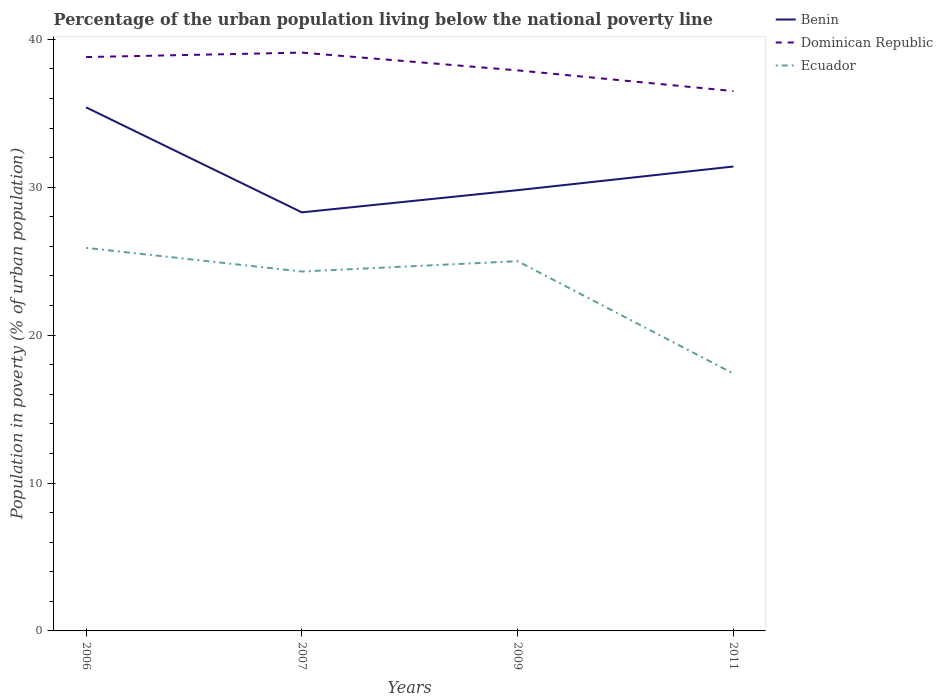How many different coloured lines are there?
Give a very brief answer. 3. Does the line corresponding to Benin intersect with the line corresponding to Dominican Republic?
Provide a short and direct response. No. Is the number of lines equal to the number of legend labels?
Make the answer very short. Yes. Across all years, what is the maximum percentage of the urban population living below the national poverty line in Dominican Republic?
Your response must be concise. 36.5. In which year was the percentage of the urban population living below the national poverty line in Ecuador maximum?
Give a very brief answer. 2011. What is the total percentage of the urban population living below the national poverty line in Dominican Republic in the graph?
Offer a very short reply. 2.6. What is the difference between the highest and the second highest percentage of the urban population living below the national poverty line in Benin?
Provide a short and direct response. 7.1. What is the difference between the highest and the lowest percentage of the urban population living below the national poverty line in Dominican Republic?
Your answer should be compact. 2. How many lines are there?
Keep it short and to the point. 3. What is the difference between two consecutive major ticks on the Y-axis?
Provide a short and direct response. 10. Does the graph contain grids?
Provide a short and direct response. No. Where does the legend appear in the graph?
Provide a short and direct response. Top right. How many legend labels are there?
Your answer should be very brief. 3. What is the title of the graph?
Keep it short and to the point. Percentage of the urban population living below the national poverty line. Does "Norway" appear as one of the legend labels in the graph?
Provide a short and direct response. No. What is the label or title of the Y-axis?
Your response must be concise. Population in poverty (% of urban population). What is the Population in poverty (% of urban population) of Benin in 2006?
Offer a terse response. 35.4. What is the Population in poverty (% of urban population) of Dominican Republic in 2006?
Offer a very short reply. 38.8. What is the Population in poverty (% of urban population) in Ecuador in 2006?
Your response must be concise. 25.9. What is the Population in poverty (% of urban population) in Benin in 2007?
Your answer should be very brief. 28.3. What is the Population in poverty (% of urban population) in Dominican Republic in 2007?
Offer a terse response. 39.1. What is the Population in poverty (% of urban population) in Ecuador in 2007?
Give a very brief answer. 24.3. What is the Population in poverty (% of urban population) in Benin in 2009?
Give a very brief answer. 29.8. What is the Population in poverty (% of urban population) in Dominican Republic in 2009?
Ensure brevity in your answer.  37.9. What is the Population in poverty (% of urban population) in Ecuador in 2009?
Give a very brief answer. 25. What is the Population in poverty (% of urban population) of Benin in 2011?
Give a very brief answer. 31.4. What is the Population in poverty (% of urban population) in Dominican Republic in 2011?
Your response must be concise. 36.5. What is the Population in poverty (% of urban population) of Ecuador in 2011?
Your response must be concise. 17.4. Across all years, what is the maximum Population in poverty (% of urban population) in Benin?
Make the answer very short. 35.4. Across all years, what is the maximum Population in poverty (% of urban population) of Dominican Republic?
Your answer should be very brief. 39.1. Across all years, what is the maximum Population in poverty (% of urban population) of Ecuador?
Make the answer very short. 25.9. Across all years, what is the minimum Population in poverty (% of urban population) of Benin?
Provide a succinct answer. 28.3. Across all years, what is the minimum Population in poverty (% of urban population) of Dominican Republic?
Provide a succinct answer. 36.5. What is the total Population in poverty (% of urban population) in Benin in the graph?
Offer a very short reply. 124.9. What is the total Population in poverty (% of urban population) in Dominican Republic in the graph?
Keep it short and to the point. 152.3. What is the total Population in poverty (% of urban population) of Ecuador in the graph?
Your response must be concise. 92.6. What is the difference between the Population in poverty (% of urban population) of Benin in 2006 and that in 2007?
Make the answer very short. 7.1. What is the difference between the Population in poverty (% of urban population) of Dominican Republic in 2006 and that in 2007?
Your response must be concise. -0.3. What is the difference between the Population in poverty (% of urban population) in Ecuador in 2006 and that in 2007?
Give a very brief answer. 1.6. What is the difference between the Population in poverty (% of urban population) in Dominican Republic in 2006 and that in 2009?
Your response must be concise. 0.9. What is the difference between the Population in poverty (% of urban population) in Ecuador in 2006 and that in 2009?
Give a very brief answer. 0.9. What is the difference between the Population in poverty (% of urban population) of Benin in 2006 and that in 2011?
Make the answer very short. 4. What is the difference between the Population in poverty (% of urban population) of Benin in 2007 and that in 2009?
Your answer should be very brief. -1.5. What is the difference between the Population in poverty (% of urban population) in Dominican Republic in 2007 and that in 2009?
Offer a terse response. 1.2. What is the difference between the Population in poverty (% of urban population) of Benin in 2007 and that in 2011?
Make the answer very short. -3.1. What is the difference between the Population in poverty (% of urban population) of Ecuador in 2007 and that in 2011?
Offer a terse response. 6.9. What is the difference between the Population in poverty (% of urban population) of Ecuador in 2009 and that in 2011?
Your answer should be very brief. 7.6. What is the difference between the Population in poverty (% of urban population) of Benin in 2006 and the Population in poverty (% of urban population) of Dominican Republic in 2009?
Keep it short and to the point. -2.5. What is the difference between the Population in poverty (% of urban population) in Benin in 2006 and the Population in poverty (% of urban population) in Dominican Republic in 2011?
Keep it short and to the point. -1.1. What is the difference between the Population in poverty (% of urban population) in Dominican Republic in 2006 and the Population in poverty (% of urban population) in Ecuador in 2011?
Offer a terse response. 21.4. What is the difference between the Population in poverty (% of urban population) of Benin in 2007 and the Population in poverty (% of urban population) of Ecuador in 2009?
Provide a short and direct response. 3.3. What is the difference between the Population in poverty (% of urban population) in Dominican Republic in 2007 and the Population in poverty (% of urban population) in Ecuador in 2009?
Your answer should be compact. 14.1. What is the difference between the Population in poverty (% of urban population) of Benin in 2007 and the Population in poverty (% of urban population) of Dominican Republic in 2011?
Your response must be concise. -8.2. What is the difference between the Population in poverty (% of urban population) in Benin in 2007 and the Population in poverty (% of urban population) in Ecuador in 2011?
Give a very brief answer. 10.9. What is the difference between the Population in poverty (% of urban population) of Dominican Republic in 2007 and the Population in poverty (% of urban population) of Ecuador in 2011?
Give a very brief answer. 21.7. What is the difference between the Population in poverty (% of urban population) of Benin in 2009 and the Population in poverty (% of urban population) of Dominican Republic in 2011?
Make the answer very short. -6.7. What is the difference between the Population in poverty (% of urban population) in Dominican Republic in 2009 and the Population in poverty (% of urban population) in Ecuador in 2011?
Provide a succinct answer. 20.5. What is the average Population in poverty (% of urban population) of Benin per year?
Your response must be concise. 31.23. What is the average Population in poverty (% of urban population) in Dominican Republic per year?
Make the answer very short. 38.08. What is the average Population in poverty (% of urban population) of Ecuador per year?
Offer a terse response. 23.15. In the year 2006, what is the difference between the Population in poverty (% of urban population) in Benin and Population in poverty (% of urban population) in Dominican Republic?
Provide a short and direct response. -3.4. In the year 2006, what is the difference between the Population in poverty (% of urban population) in Dominican Republic and Population in poverty (% of urban population) in Ecuador?
Offer a terse response. 12.9. In the year 2007, what is the difference between the Population in poverty (% of urban population) of Benin and Population in poverty (% of urban population) of Ecuador?
Give a very brief answer. 4. In the year 2009, what is the difference between the Population in poverty (% of urban population) in Dominican Republic and Population in poverty (% of urban population) in Ecuador?
Offer a terse response. 12.9. In the year 2011, what is the difference between the Population in poverty (% of urban population) of Benin and Population in poverty (% of urban population) of Dominican Republic?
Your answer should be very brief. -5.1. In the year 2011, what is the difference between the Population in poverty (% of urban population) of Benin and Population in poverty (% of urban population) of Ecuador?
Your answer should be very brief. 14. In the year 2011, what is the difference between the Population in poverty (% of urban population) of Dominican Republic and Population in poverty (% of urban population) of Ecuador?
Keep it short and to the point. 19.1. What is the ratio of the Population in poverty (% of urban population) in Benin in 2006 to that in 2007?
Give a very brief answer. 1.25. What is the ratio of the Population in poverty (% of urban population) in Dominican Republic in 2006 to that in 2007?
Keep it short and to the point. 0.99. What is the ratio of the Population in poverty (% of urban population) in Ecuador in 2006 to that in 2007?
Give a very brief answer. 1.07. What is the ratio of the Population in poverty (% of urban population) of Benin in 2006 to that in 2009?
Give a very brief answer. 1.19. What is the ratio of the Population in poverty (% of urban population) of Dominican Republic in 2006 to that in 2009?
Give a very brief answer. 1.02. What is the ratio of the Population in poverty (% of urban population) of Ecuador in 2006 to that in 2009?
Give a very brief answer. 1.04. What is the ratio of the Population in poverty (% of urban population) in Benin in 2006 to that in 2011?
Provide a short and direct response. 1.13. What is the ratio of the Population in poverty (% of urban population) of Dominican Republic in 2006 to that in 2011?
Offer a very short reply. 1.06. What is the ratio of the Population in poverty (% of urban population) of Ecuador in 2006 to that in 2011?
Offer a very short reply. 1.49. What is the ratio of the Population in poverty (% of urban population) of Benin in 2007 to that in 2009?
Your answer should be compact. 0.95. What is the ratio of the Population in poverty (% of urban population) of Dominican Republic in 2007 to that in 2009?
Your answer should be compact. 1.03. What is the ratio of the Population in poverty (% of urban population) in Benin in 2007 to that in 2011?
Keep it short and to the point. 0.9. What is the ratio of the Population in poverty (% of urban population) of Dominican Republic in 2007 to that in 2011?
Keep it short and to the point. 1.07. What is the ratio of the Population in poverty (% of urban population) of Ecuador in 2007 to that in 2011?
Your answer should be very brief. 1.4. What is the ratio of the Population in poverty (% of urban population) in Benin in 2009 to that in 2011?
Provide a short and direct response. 0.95. What is the ratio of the Population in poverty (% of urban population) of Dominican Republic in 2009 to that in 2011?
Keep it short and to the point. 1.04. What is the ratio of the Population in poverty (% of urban population) in Ecuador in 2009 to that in 2011?
Keep it short and to the point. 1.44. What is the difference between the highest and the second highest Population in poverty (% of urban population) of Ecuador?
Ensure brevity in your answer.  0.9. What is the difference between the highest and the lowest Population in poverty (% of urban population) in Ecuador?
Keep it short and to the point. 8.5. 